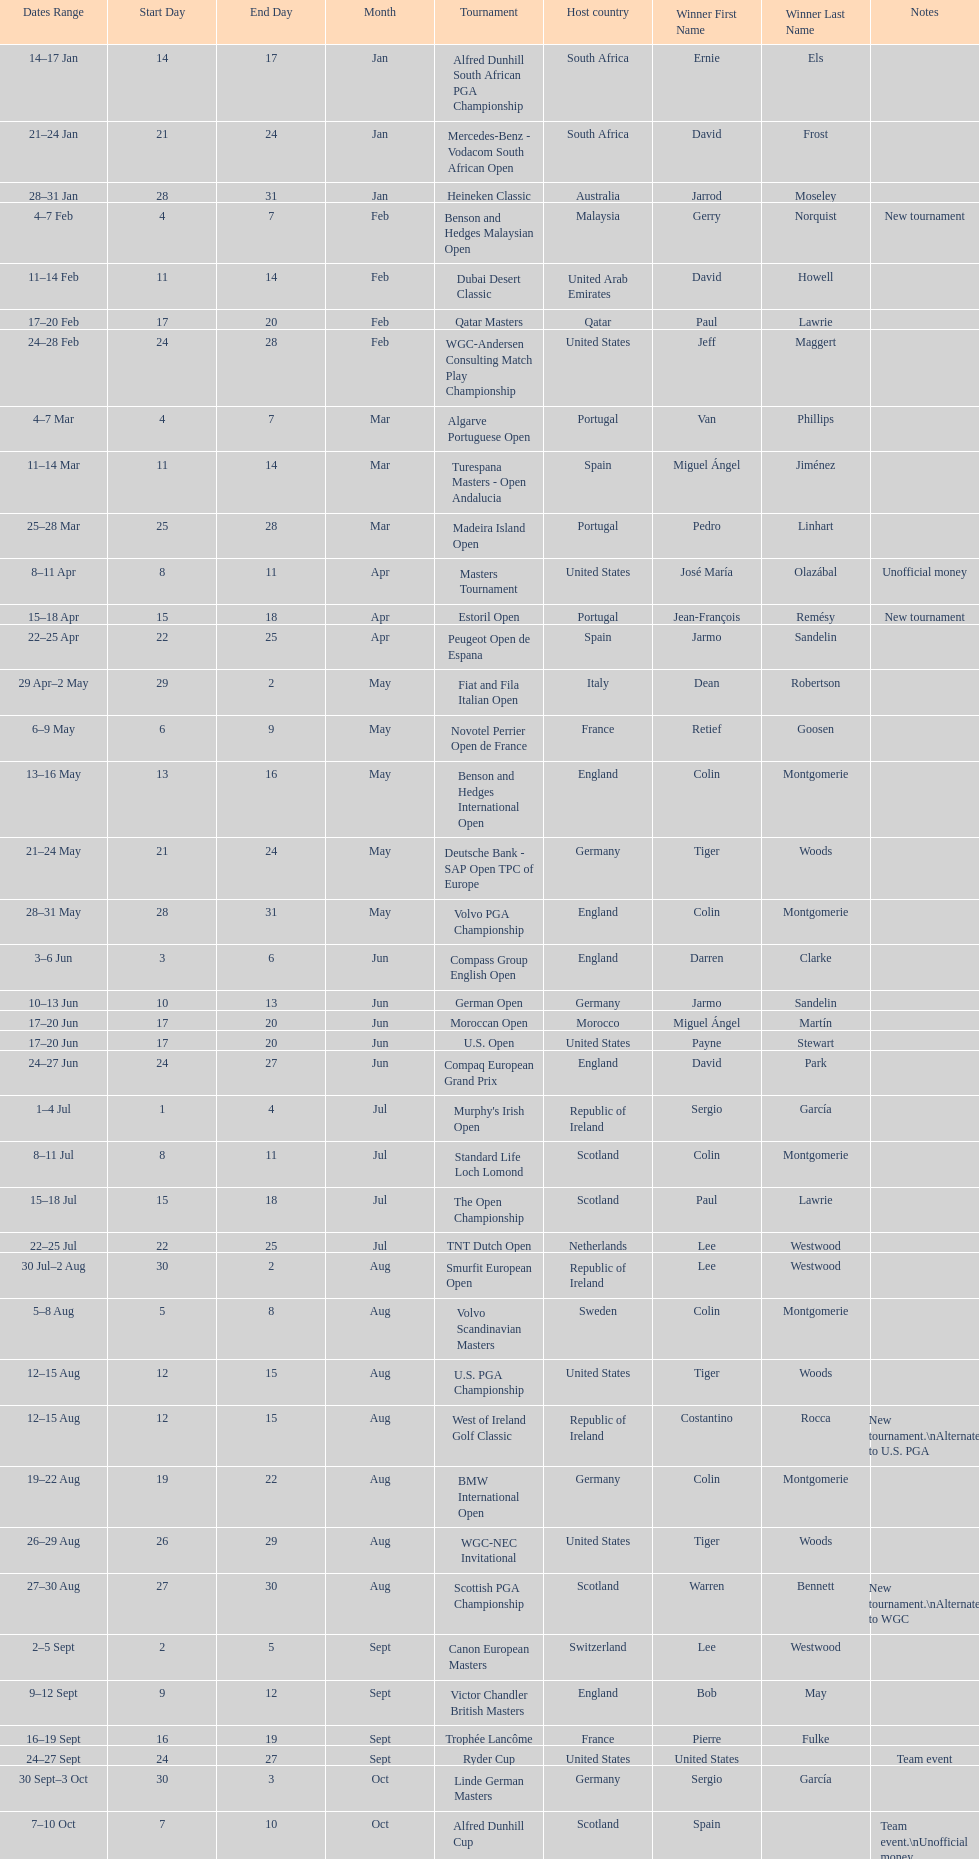Does any country have more than 5 winners? Yes. 